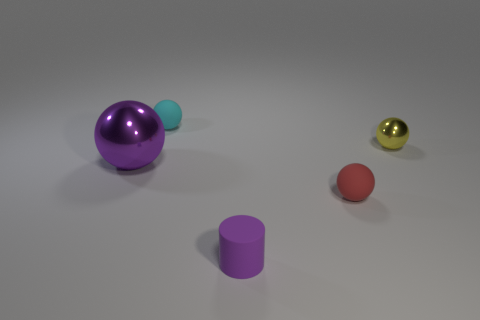Subtract all green spheres. Subtract all red cylinders. How many spheres are left? 4 Add 1 big metallic spheres. How many objects exist? 6 Subtract all cylinders. How many objects are left? 4 Add 5 tiny cyan rubber spheres. How many tiny cyan rubber spheres are left? 6 Add 4 big yellow matte cubes. How many big yellow matte cubes exist? 4 Subtract 1 yellow balls. How many objects are left? 4 Subtract all cylinders. Subtract all yellow shiny objects. How many objects are left? 3 